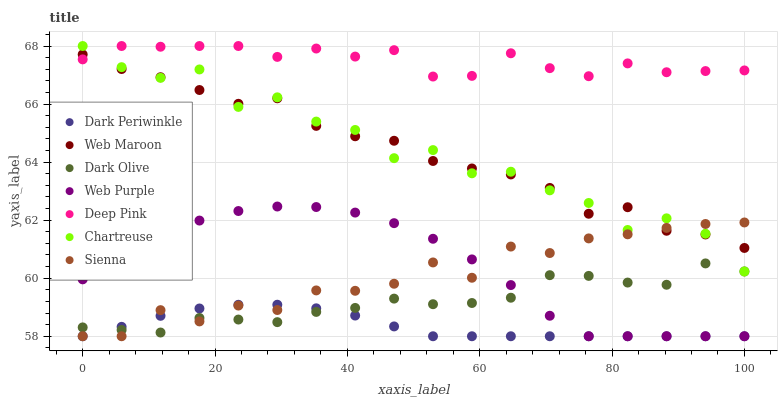Does Dark Periwinkle have the minimum area under the curve?
Answer yes or no. Yes. Does Deep Pink have the maximum area under the curve?
Answer yes or no. Yes. Does Dark Olive have the minimum area under the curve?
Answer yes or no. No. Does Dark Olive have the maximum area under the curve?
Answer yes or no. No. Is Dark Periwinkle the smoothest?
Answer yes or no. Yes. Is Chartreuse the roughest?
Answer yes or no. Yes. Is Dark Olive the smoothest?
Answer yes or no. No. Is Dark Olive the roughest?
Answer yes or no. No. Does Web Purple have the lowest value?
Answer yes or no. Yes. Does Dark Olive have the lowest value?
Answer yes or no. No. Does Chartreuse have the highest value?
Answer yes or no. Yes. Does Dark Olive have the highest value?
Answer yes or no. No. Is Dark Olive less than Web Maroon?
Answer yes or no. Yes. Is Chartreuse greater than Web Purple?
Answer yes or no. Yes. Does Dark Periwinkle intersect Web Purple?
Answer yes or no. Yes. Is Dark Periwinkle less than Web Purple?
Answer yes or no. No. Is Dark Periwinkle greater than Web Purple?
Answer yes or no. No. Does Dark Olive intersect Web Maroon?
Answer yes or no. No. 